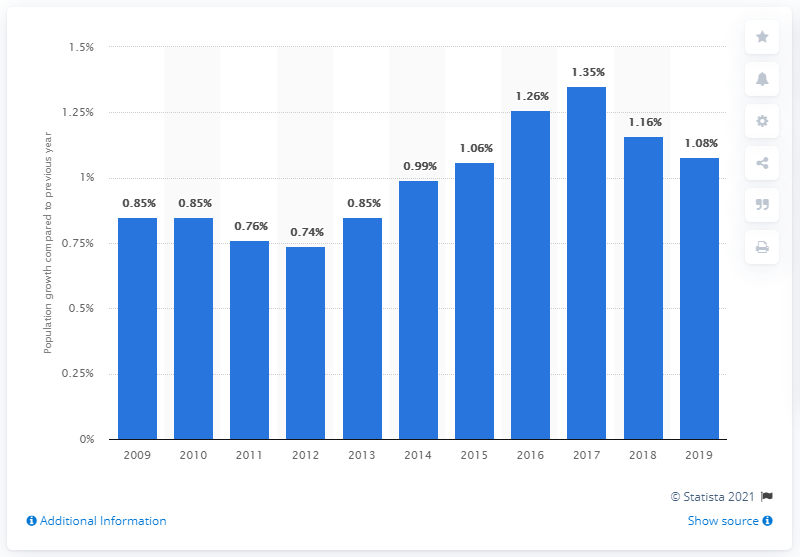List a handful of essential elements in this visual. In 2019, the population of Sweden increased by 1.08%. 